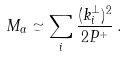Convert formula to latex. <formula><loc_0><loc_0><loc_500><loc_500>M _ { \alpha } \simeq \sum _ { i } \frac { ( k ^ { \perp } _ { i } ) ^ { 2 } } { 2 P ^ { + } } \, .</formula> 